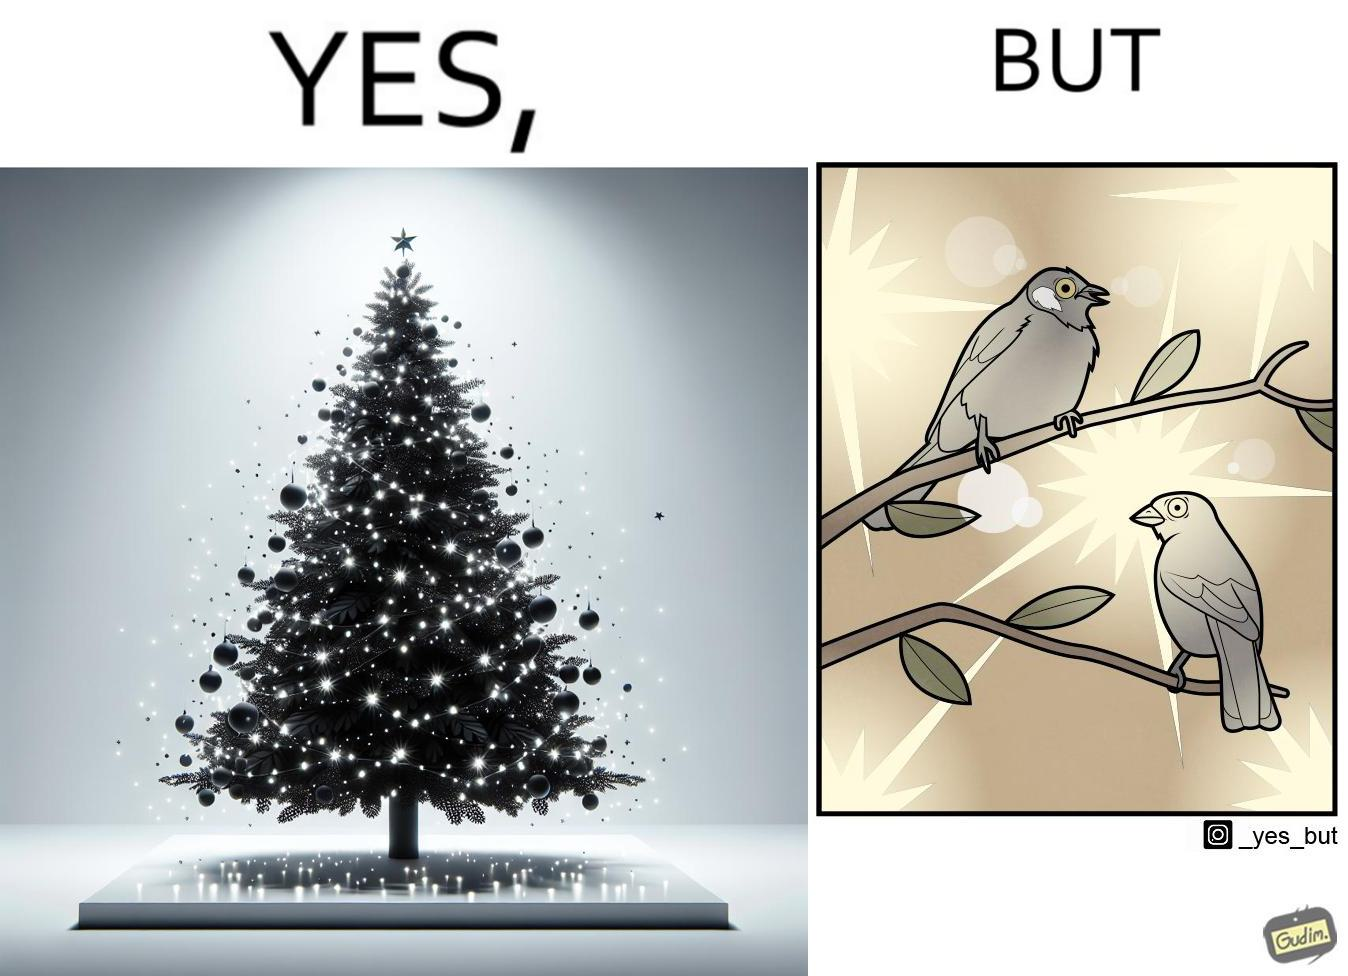Explain the humor or irony in this image. The images are ironic since they show how putting a lot of lights as decorations on trees make them beautiful to look at for us but cause trouble to the birds who actually live on trees for no good reason 